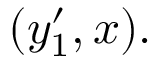Convert formula to latex. <formula><loc_0><loc_0><loc_500><loc_500>( y _ { 1 } ^ { \prime } , x ) .</formula> 